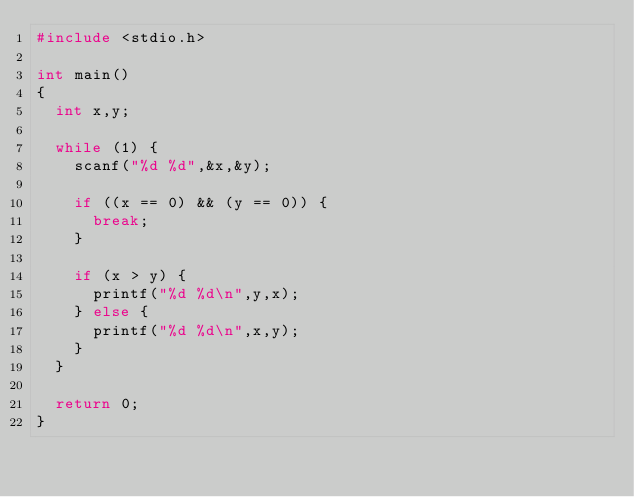Convert code to text. <code><loc_0><loc_0><loc_500><loc_500><_C_>#include <stdio.h>

int main()
{
	int x,y;
	
	while (1) {
		scanf("%d %d",&x,&y);
		
		if ((x == 0) && (y == 0)) {
			break;
		}
		
		if (x > y) {
			printf("%d %d\n",y,x);
		} else {
			printf("%d %d\n",x,y);
		}
	}
	
	return 0;
}</code> 